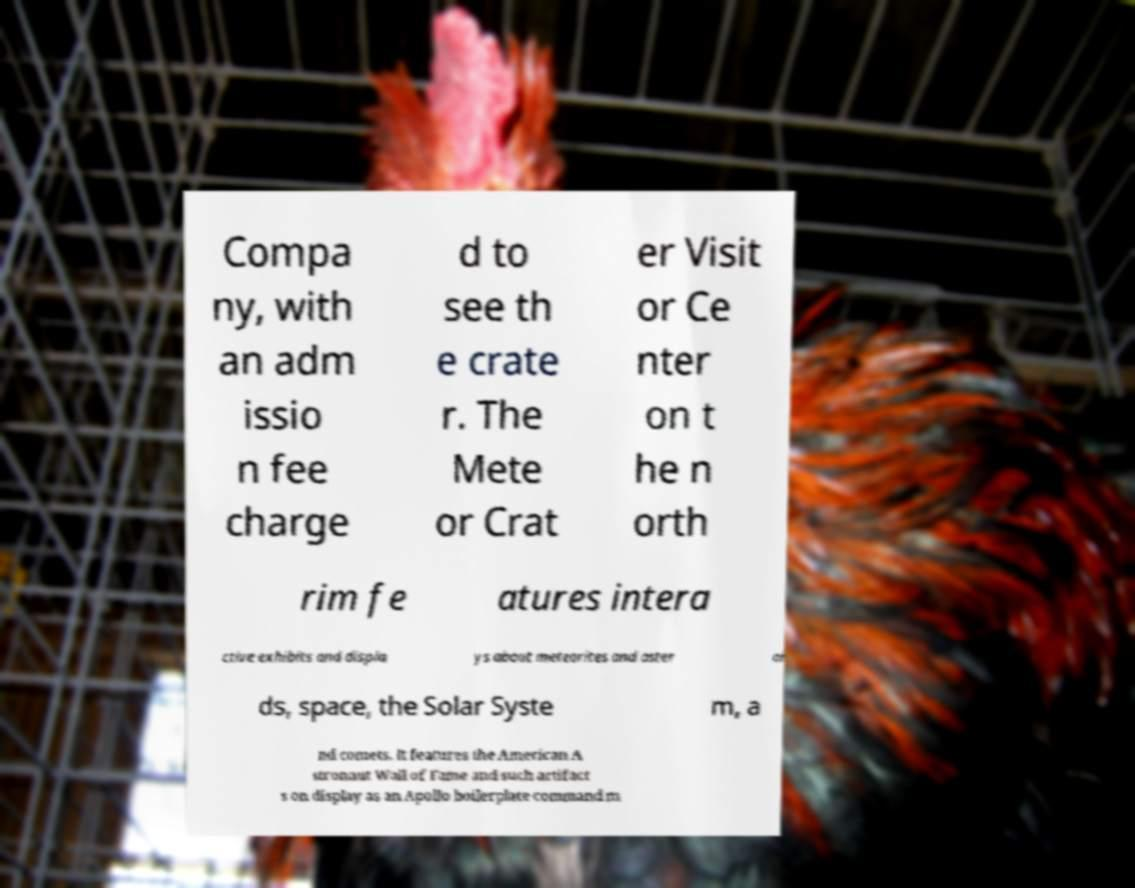For documentation purposes, I need the text within this image transcribed. Could you provide that? Compa ny, with an adm issio n fee charge d to see th e crate r. The Mete or Crat er Visit or Ce nter on t he n orth rim fe atures intera ctive exhibits and displa ys about meteorites and aster oi ds, space, the Solar Syste m, a nd comets. It features the American A stronaut Wall of Fame and such artifact s on display as an Apollo boilerplate command m 